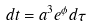Convert formula to latex. <formula><loc_0><loc_0><loc_500><loc_500>d t = a ^ { 3 } e ^ { \phi } d \tau</formula> 